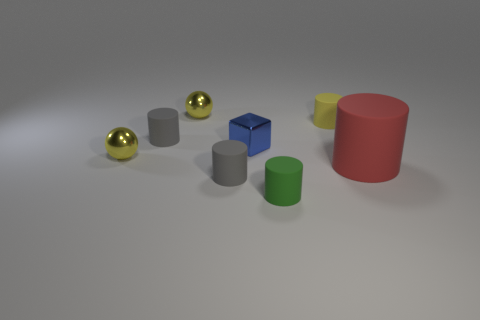Subtract all small gray cylinders. How many cylinders are left? 3 Subtract 1 cylinders. How many cylinders are left? 4 Add 1 cylinders. How many objects exist? 9 Subtract all red cylinders. How many cylinders are left? 4 Subtract all cubes. How many objects are left? 7 Add 1 big brown matte objects. How many big brown matte objects exist? 1 Subtract 0 brown spheres. How many objects are left? 8 Subtract all green balls. Subtract all red cubes. How many balls are left? 2 Subtract all cyan blocks. How many purple balls are left? 0 Subtract all gray rubber things. Subtract all yellow things. How many objects are left? 3 